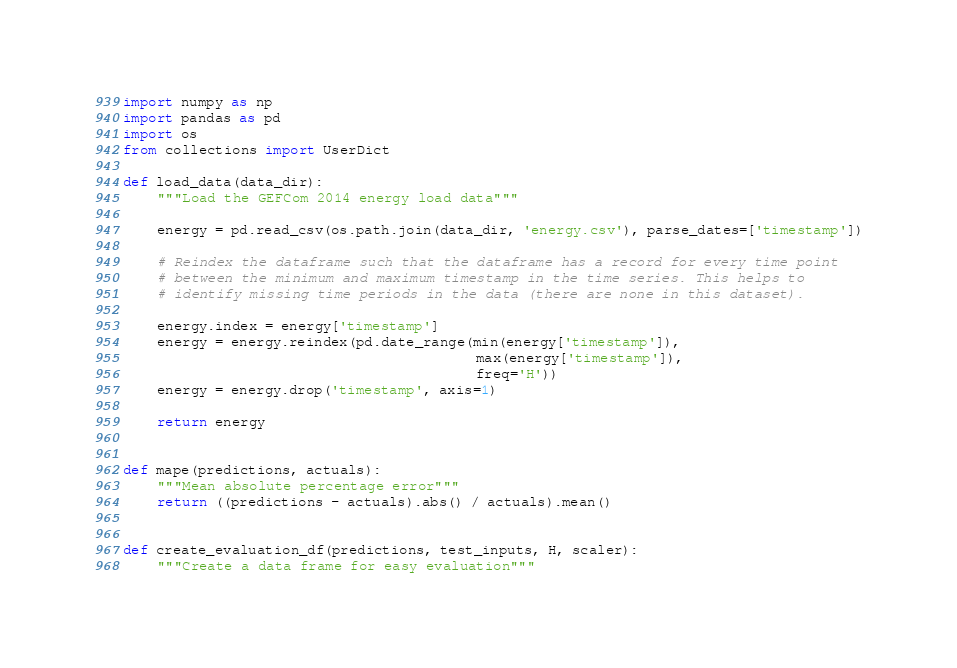<code> <loc_0><loc_0><loc_500><loc_500><_Python_>import numpy as np
import pandas as pd
import os
from collections import UserDict

def load_data(data_dir):
    """Load the GEFCom 2014 energy load data"""

    energy = pd.read_csv(os.path.join(data_dir, 'energy.csv'), parse_dates=['timestamp'])

    # Reindex the dataframe such that the dataframe has a record for every time point
    # between the minimum and maximum timestamp in the time series. This helps to 
    # identify missing time periods in the data (there are none in this dataset).

    energy.index = energy['timestamp']
    energy = energy.reindex(pd.date_range(min(energy['timestamp']),
                                          max(energy['timestamp']),
                                          freq='H'))
    energy = energy.drop('timestamp', axis=1)

    return energy


def mape(predictions, actuals):
    """Mean absolute percentage error"""
    return ((predictions - actuals).abs() / actuals).mean()


def create_evaluation_df(predictions, test_inputs, H, scaler):
    """Create a data frame for easy evaluation"""</code> 